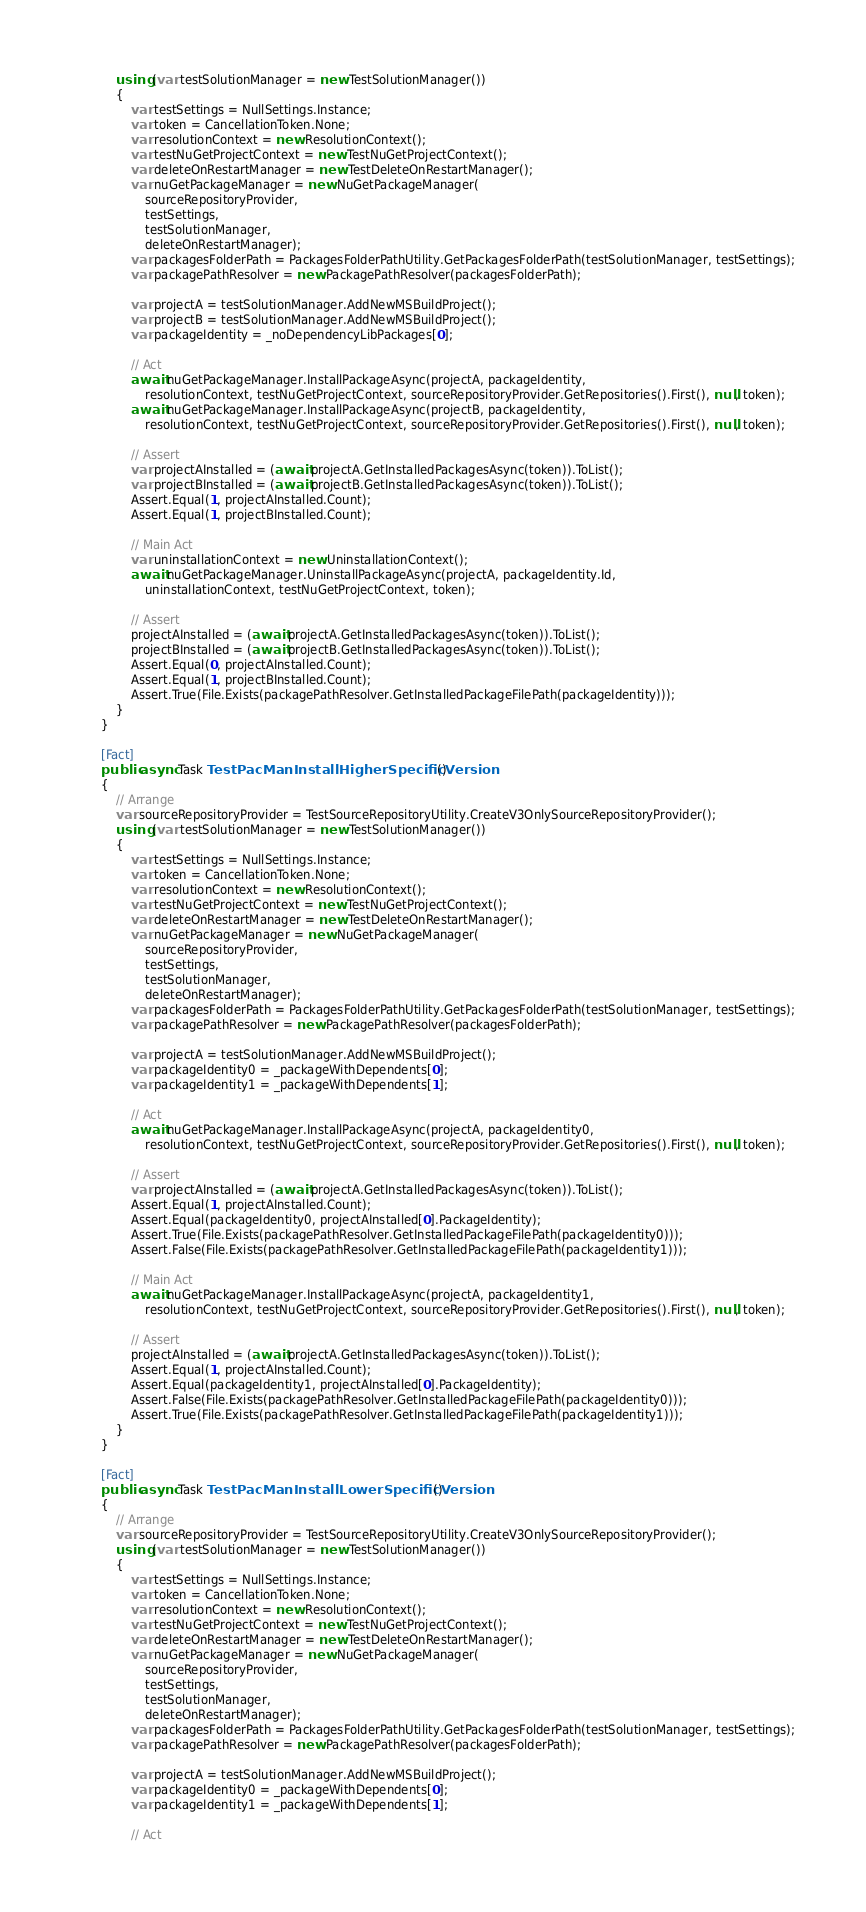Convert code to text. <code><loc_0><loc_0><loc_500><loc_500><_C#_>            using (var testSolutionManager = new TestSolutionManager())
            {
                var testSettings = NullSettings.Instance;
                var token = CancellationToken.None;
                var resolutionContext = new ResolutionContext();
                var testNuGetProjectContext = new TestNuGetProjectContext();
                var deleteOnRestartManager = new TestDeleteOnRestartManager();
                var nuGetPackageManager = new NuGetPackageManager(
                    sourceRepositoryProvider,
                    testSettings,
                    testSolutionManager,
                    deleteOnRestartManager);
                var packagesFolderPath = PackagesFolderPathUtility.GetPackagesFolderPath(testSolutionManager, testSettings);
                var packagePathResolver = new PackagePathResolver(packagesFolderPath);

                var projectA = testSolutionManager.AddNewMSBuildProject();
                var projectB = testSolutionManager.AddNewMSBuildProject();
                var packageIdentity = _noDependencyLibPackages[0];

                // Act
                await nuGetPackageManager.InstallPackageAsync(projectA, packageIdentity,
                    resolutionContext, testNuGetProjectContext, sourceRepositoryProvider.GetRepositories().First(), null, token);
                await nuGetPackageManager.InstallPackageAsync(projectB, packageIdentity,
                    resolutionContext, testNuGetProjectContext, sourceRepositoryProvider.GetRepositories().First(), null, token);

                // Assert
                var projectAInstalled = (await projectA.GetInstalledPackagesAsync(token)).ToList();
                var projectBInstalled = (await projectB.GetInstalledPackagesAsync(token)).ToList();
                Assert.Equal(1, projectAInstalled.Count);
                Assert.Equal(1, projectBInstalled.Count);

                // Main Act
                var uninstallationContext = new UninstallationContext();
                await nuGetPackageManager.UninstallPackageAsync(projectA, packageIdentity.Id,
                    uninstallationContext, testNuGetProjectContext, token);

                // Assert
                projectAInstalled = (await projectA.GetInstalledPackagesAsync(token)).ToList();
                projectBInstalled = (await projectB.GetInstalledPackagesAsync(token)).ToList();
                Assert.Equal(0, projectAInstalled.Count);
                Assert.Equal(1, projectBInstalled.Count);
                Assert.True(File.Exists(packagePathResolver.GetInstalledPackageFilePath(packageIdentity)));
            }
        }

        [Fact]
        public async Task TestPacManInstallHigherSpecificVersion()
        {
            // Arrange
            var sourceRepositoryProvider = TestSourceRepositoryUtility.CreateV3OnlySourceRepositoryProvider();
            using (var testSolutionManager = new TestSolutionManager())
            {
                var testSettings = NullSettings.Instance;
                var token = CancellationToken.None;
                var resolutionContext = new ResolutionContext();
                var testNuGetProjectContext = new TestNuGetProjectContext();
                var deleteOnRestartManager = new TestDeleteOnRestartManager();
                var nuGetPackageManager = new NuGetPackageManager(
                    sourceRepositoryProvider,
                    testSettings,
                    testSolutionManager,
                    deleteOnRestartManager);
                var packagesFolderPath = PackagesFolderPathUtility.GetPackagesFolderPath(testSolutionManager, testSettings);
                var packagePathResolver = new PackagePathResolver(packagesFolderPath);

                var projectA = testSolutionManager.AddNewMSBuildProject();
                var packageIdentity0 = _packageWithDependents[0];
                var packageIdentity1 = _packageWithDependents[1];

                // Act
                await nuGetPackageManager.InstallPackageAsync(projectA, packageIdentity0,
                    resolutionContext, testNuGetProjectContext, sourceRepositoryProvider.GetRepositories().First(), null, token);

                // Assert
                var projectAInstalled = (await projectA.GetInstalledPackagesAsync(token)).ToList();
                Assert.Equal(1, projectAInstalled.Count);
                Assert.Equal(packageIdentity0, projectAInstalled[0].PackageIdentity);
                Assert.True(File.Exists(packagePathResolver.GetInstalledPackageFilePath(packageIdentity0)));
                Assert.False(File.Exists(packagePathResolver.GetInstalledPackageFilePath(packageIdentity1)));

                // Main Act
                await nuGetPackageManager.InstallPackageAsync(projectA, packageIdentity1,
                    resolutionContext, testNuGetProjectContext, sourceRepositoryProvider.GetRepositories().First(), null, token);

                // Assert
                projectAInstalled = (await projectA.GetInstalledPackagesAsync(token)).ToList();
                Assert.Equal(1, projectAInstalled.Count);
                Assert.Equal(packageIdentity1, projectAInstalled[0].PackageIdentity);
                Assert.False(File.Exists(packagePathResolver.GetInstalledPackageFilePath(packageIdentity0)));
                Assert.True(File.Exists(packagePathResolver.GetInstalledPackageFilePath(packageIdentity1)));
            }
        }

        [Fact]
        public async Task TestPacManInstallLowerSpecificVersion()
        {
            // Arrange
            var sourceRepositoryProvider = TestSourceRepositoryUtility.CreateV3OnlySourceRepositoryProvider();
            using (var testSolutionManager = new TestSolutionManager())
            {
                var testSettings = NullSettings.Instance;
                var token = CancellationToken.None;
                var resolutionContext = new ResolutionContext();
                var testNuGetProjectContext = new TestNuGetProjectContext();
                var deleteOnRestartManager = new TestDeleteOnRestartManager();
                var nuGetPackageManager = new NuGetPackageManager(
                    sourceRepositoryProvider,
                    testSettings,
                    testSolutionManager,
                    deleteOnRestartManager);
                var packagesFolderPath = PackagesFolderPathUtility.GetPackagesFolderPath(testSolutionManager, testSettings);
                var packagePathResolver = new PackagePathResolver(packagesFolderPath);

                var projectA = testSolutionManager.AddNewMSBuildProject();
                var packageIdentity0 = _packageWithDependents[0];
                var packageIdentity1 = _packageWithDependents[1];

                // Act</code> 